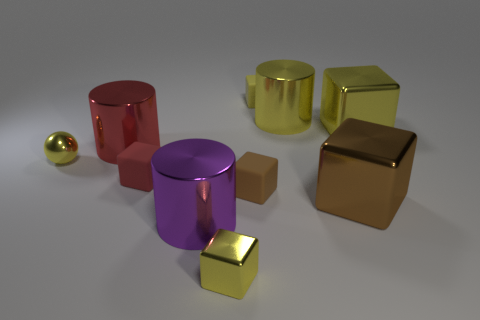What is the size of the other metal cube that is the same color as the small metal cube?
Give a very brief answer. Large. What is the size of the red metallic cylinder?
Make the answer very short. Large. What number of tiny metallic objects are in front of the red cube?
Offer a terse response. 1. How big is the yellow shiny cube behind the small metal thing that is in front of the tiny brown rubber thing?
Give a very brief answer. Large. There is a red object in front of the red cylinder; does it have the same shape as the tiny yellow object that is behind the tiny yellow ball?
Keep it short and to the point. Yes. There is a matte object that is behind the tiny yellow metal object that is behind the large purple cylinder; what is its shape?
Ensure brevity in your answer.  Cube. What is the size of the metallic object that is both in front of the big red cylinder and on the right side of the tiny brown rubber cube?
Keep it short and to the point. Large. Is the shape of the big red object the same as the yellow object that is left of the big purple metal cylinder?
Provide a succinct answer. No. There is a purple object that is the same shape as the red metal thing; what is its size?
Make the answer very short. Large. Do the tiny metal ball and the cylinder that is in front of the big red object have the same color?
Give a very brief answer. No. 